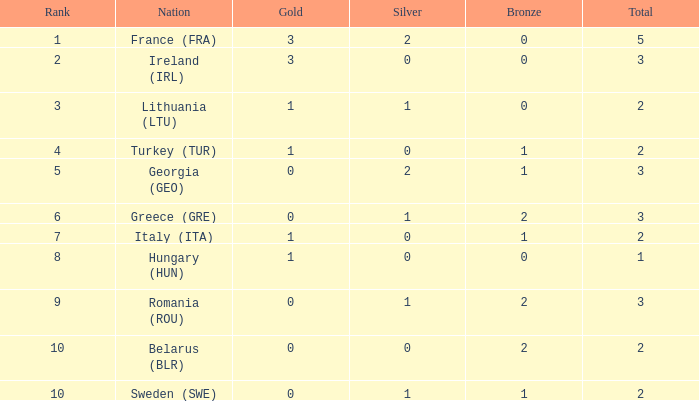What's the total number of bronze medals for Sweden (SWE) having less than 1 gold and silver? 0.0. 